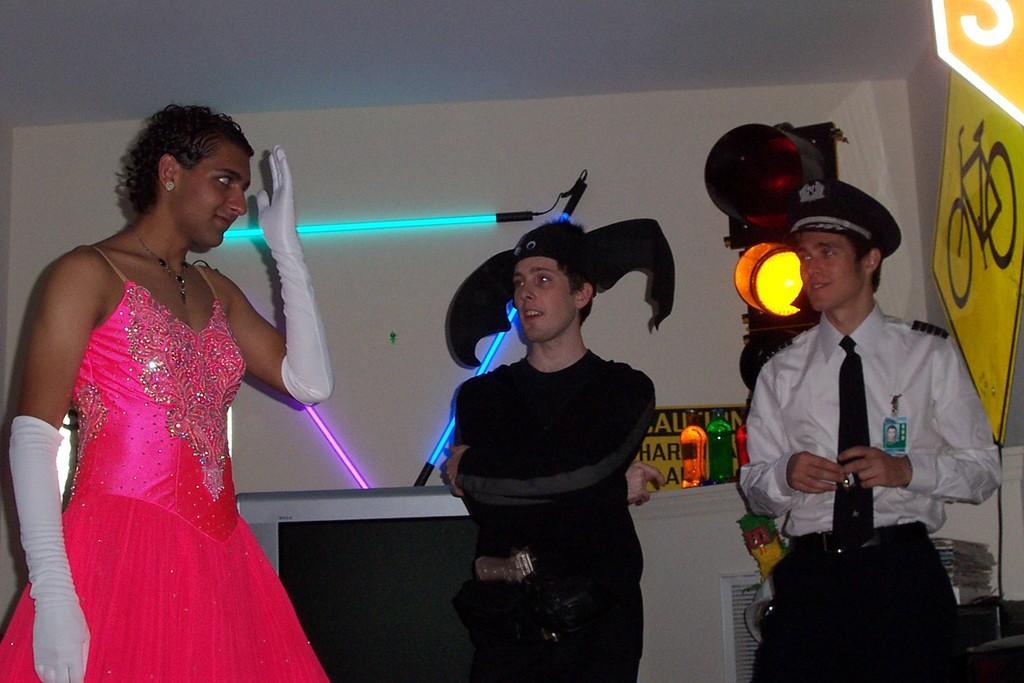How would you summarize this image in a sentence or two? There are three people standing as we can see at the bottom of this image. We can see a wall in the background and there are lights and posters are attached to it. There is a traffic signal light and a traffic sign board is present on the right side of this image. 